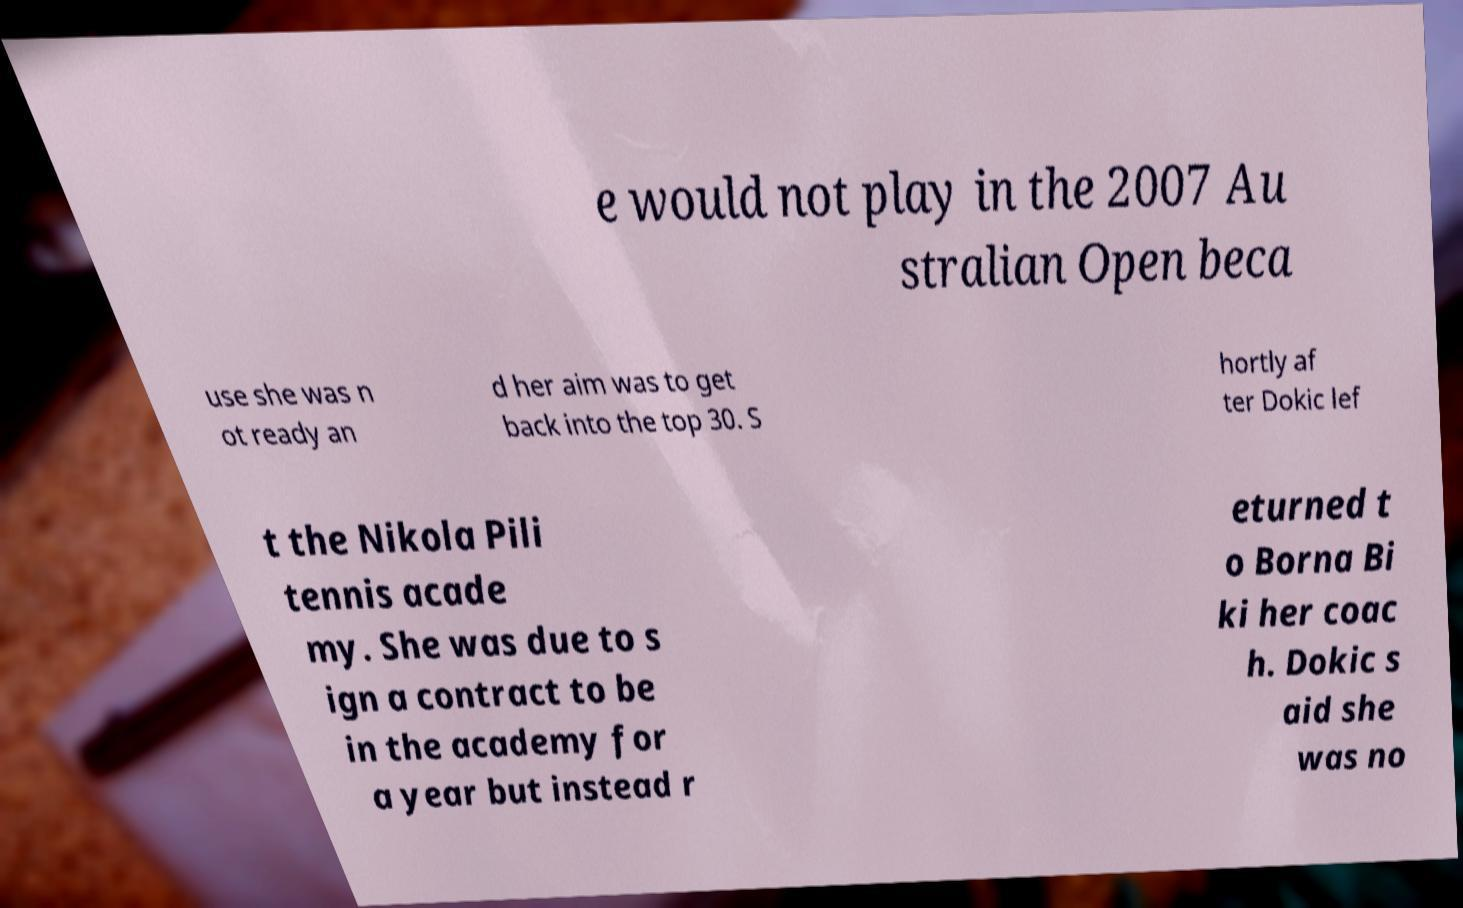Can you accurately transcribe the text from the provided image for me? e would not play in the 2007 Au stralian Open beca use she was n ot ready an d her aim was to get back into the top 30. S hortly af ter Dokic lef t the Nikola Pili tennis acade my. She was due to s ign a contract to be in the academy for a year but instead r eturned t o Borna Bi ki her coac h. Dokic s aid she was no 